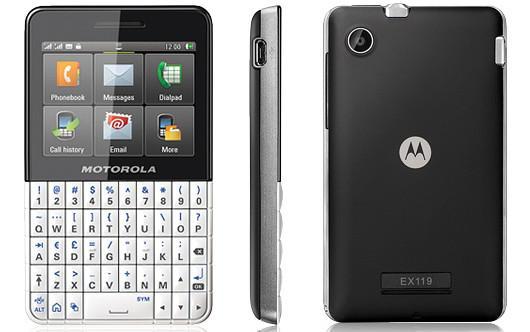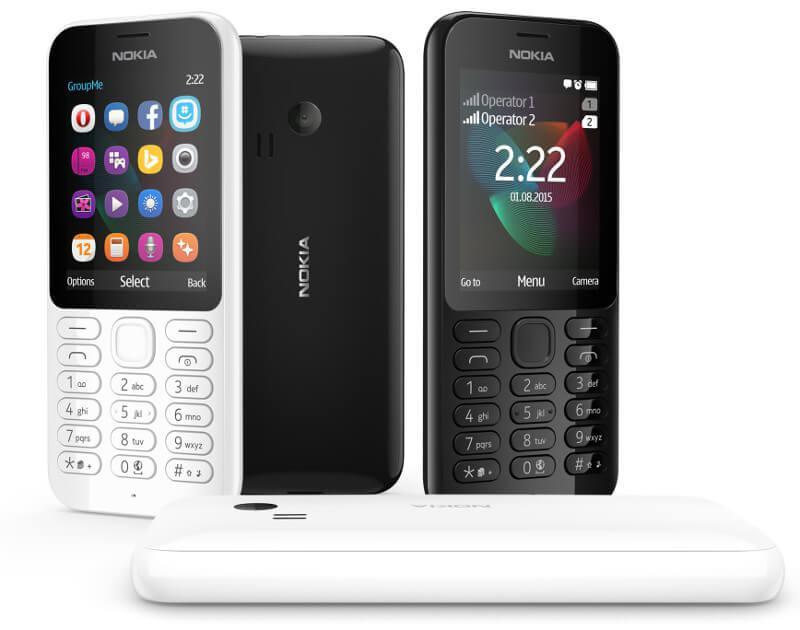The first image is the image on the left, the second image is the image on the right. Assess this claim about the two images: "The right image shows exactly three phones, which are displayed upright and spaced apart instead of overlapping.". Correct or not? Answer yes or no. No. The first image is the image on the left, the second image is the image on the right. Considering the images on both sides, is "The left and right image contains the same number of phones that a vertical." valid? Answer yes or no. Yes. 